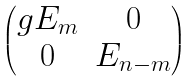Convert formula to latex. <formula><loc_0><loc_0><loc_500><loc_500>\begin{pmatrix} g E _ { m } & 0 \\ 0 & E _ { n - m } \end{pmatrix}</formula> 